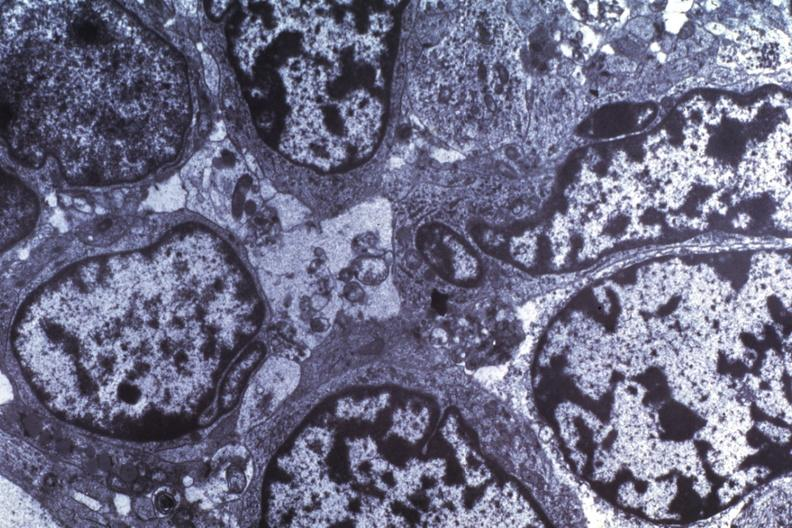what does this image show?
Answer the question using a single word or phrase. Dr garcia tumors 63 